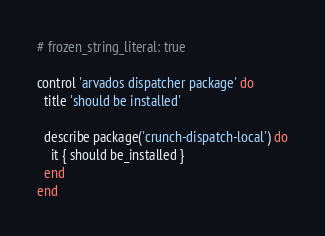Convert code to text. <code><loc_0><loc_0><loc_500><loc_500><_Ruby_># frozen_string_literal: true

control 'arvados dispatcher package' do
  title 'should be installed'

  describe package('crunch-dispatch-local') do
    it { should be_installed }
  end
end
</code> 